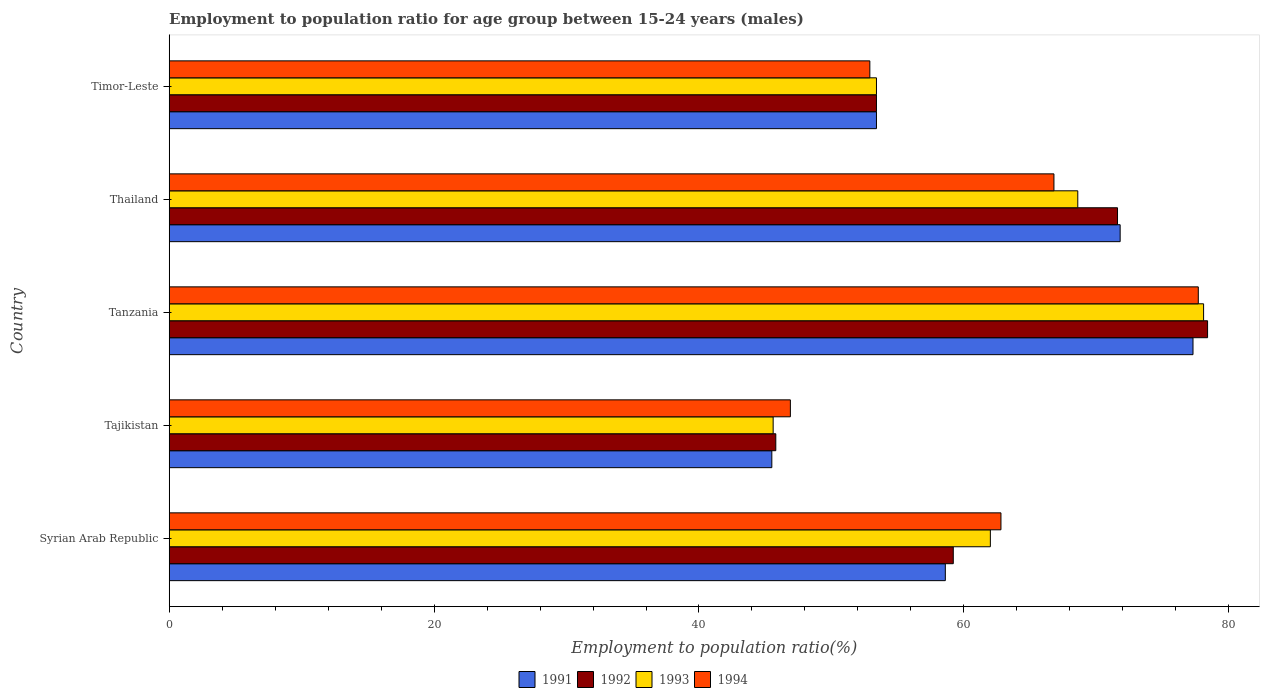How many different coloured bars are there?
Provide a succinct answer. 4. Are the number of bars per tick equal to the number of legend labels?
Keep it short and to the point. Yes. How many bars are there on the 4th tick from the bottom?
Provide a succinct answer. 4. What is the label of the 4th group of bars from the top?
Keep it short and to the point. Tajikistan. What is the employment to population ratio in 1991 in Thailand?
Your answer should be very brief. 71.8. Across all countries, what is the maximum employment to population ratio in 1991?
Ensure brevity in your answer.  77.3. Across all countries, what is the minimum employment to population ratio in 1992?
Ensure brevity in your answer.  45.8. In which country was the employment to population ratio in 1991 maximum?
Ensure brevity in your answer.  Tanzania. In which country was the employment to population ratio in 1993 minimum?
Your answer should be compact. Tajikistan. What is the total employment to population ratio in 1992 in the graph?
Keep it short and to the point. 308.4. What is the difference between the employment to population ratio in 1991 in Tajikistan and that in Tanzania?
Your response must be concise. -31.8. What is the difference between the employment to population ratio in 1991 in Syrian Arab Republic and the employment to population ratio in 1994 in Timor-Leste?
Ensure brevity in your answer.  5.7. What is the average employment to population ratio in 1992 per country?
Provide a short and direct response. 61.68. What is the difference between the employment to population ratio in 1991 and employment to population ratio in 1992 in Tajikistan?
Offer a very short reply. -0.3. In how many countries, is the employment to population ratio in 1993 greater than 68 %?
Keep it short and to the point. 2. What is the ratio of the employment to population ratio in 1992 in Tajikistan to that in Timor-Leste?
Provide a short and direct response. 0.86. What is the difference between the highest and the lowest employment to population ratio in 1991?
Offer a terse response. 31.8. In how many countries, is the employment to population ratio in 1991 greater than the average employment to population ratio in 1991 taken over all countries?
Ensure brevity in your answer.  2. Is it the case that in every country, the sum of the employment to population ratio in 1993 and employment to population ratio in 1994 is greater than the sum of employment to population ratio in 1991 and employment to population ratio in 1992?
Offer a terse response. No. What does the 1st bar from the top in Timor-Leste represents?
Your answer should be compact. 1994. What does the 4th bar from the bottom in Tajikistan represents?
Offer a terse response. 1994. How many bars are there?
Provide a short and direct response. 20. How many countries are there in the graph?
Your response must be concise. 5. Are the values on the major ticks of X-axis written in scientific E-notation?
Ensure brevity in your answer.  No. How are the legend labels stacked?
Ensure brevity in your answer.  Horizontal. What is the title of the graph?
Your response must be concise. Employment to population ratio for age group between 15-24 years (males). Does "1962" appear as one of the legend labels in the graph?
Your response must be concise. No. What is the label or title of the X-axis?
Make the answer very short. Employment to population ratio(%). What is the label or title of the Y-axis?
Provide a short and direct response. Country. What is the Employment to population ratio(%) in 1991 in Syrian Arab Republic?
Your answer should be compact. 58.6. What is the Employment to population ratio(%) in 1992 in Syrian Arab Republic?
Offer a very short reply. 59.2. What is the Employment to population ratio(%) in 1993 in Syrian Arab Republic?
Your answer should be very brief. 62. What is the Employment to population ratio(%) in 1994 in Syrian Arab Republic?
Offer a very short reply. 62.8. What is the Employment to population ratio(%) in 1991 in Tajikistan?
Provide a short and direct response. 45.5. What is the Employment to population ratio(%) in 1992 in Tajikistan?
Offer a very short reply. 45.8. What is the Employment to population ratio(%) of 1993 in Tajikistan?
Provide a short and direct response. 45.6. What is the Employment to population ratio(%) of 1994 in Tajikistan?
Keep it short and to the point. 46.9. What is the Employment to population ratio(%) in 1991 in Tanzania?
Keep it short and to the point. 77.3. What is the Employment to population ratio(%) of 1992 in Tanzania?
Offer a terse response. 78.4. What is the Employment to population ratio(%) in 1993 in Tanzania?
Give a very brief answer. 78.1. What is the Employment to population ratio(%) in 1994 in Tanzania?
Offer a terse response. 77.7. What is the Employment to population ratio(%) in 1991 in Thailand?
Your response must be concise. 71.8. What is the Employment to population ratio(%) in 1992 in Thailand?
Keep it short and to the point. 71.6. What is the Employment to population ratio(%) of 1993 in Thailand?
Your answer should be very brief. 68.6. What is the Employment to population ratio(%) in 1994 in Thailand?
Provide a short and direct response. 66.8. What is the Employment to population ratio(%) of 1991 in Timor-Leste?
Give a very brief answer. 53.4. What is the Employment to population ratio(%) in 1992 in Timor-Leste?
Your answer should be compact. 53.4. What is the Employment to population ratio(%) of 1993 in Timor-Leste?
Make the answer very short. 53.4. What is the Employment to population ratio(%) in 1994 in Timor-Leste?
Ensure brevity in your answer.  52.9. Across all countries, what is the maximum Employment to population ratio(%) in 1991?
Offer a terse response. 77.3. Across all countries, what is the maximum Employment to population ratio(%) in 1992?
Offer a terse response. 78.4. Across all countries, what is the maximum Employment to population ratio(%) of 1993?
Ensure brevity in your answer.  78.1. Across all countries, what is the maximum Employment to population ratio(%) of 1994?
Your answer should be very brief. 77.7. Across all countries, what is the minimum Employment to population ratio(%) in 1991?
Your response must be concise. 45.5. Across all countries, what is the minimum Employment to population ratio(%) of 1992?
Keep it short and to the point. 45.8. Across all countries, what is the minimum Employment to population ratio(%) in 1993?
Give a very brief answer. 45.6. Across all countries, what is the minimum Employment to population ratio(%) in 1994?
Your answer should be compact. 46.9. What is the total Employment to population ratio(%) in 1991 in the graph?
Your answer should be compact. 306.6. What is the total Employment to population ratio(%) in 1992 in the graph?
Your response must be concise. 308.4. What is the total Employment to population ratio(%) in 1993 in the graph?
Your response must be concise. 307.7. What is the total Employment to population ratio(%) of 1994 in the graph?
Ensure brevity in your answer.  307.1. What is the difference between the Employment to population ratio(%) of 1992 in Syrian Arab Republic and that in Tajikistan?
Keep it short and to the point. 13.4. What is the difference between the Employment to population ratio(%) in 1993 in Syrian Arab Republic and that in Tajikistan?
Your response must be concise. 16.4. What is the difference between the Employment to population ratio(%) of 1994 in Syrian Arab Republic and that in Tajikistan?
Your response must be concise. 15.9. What is the difference between the Employment to population ratio(%) in 1991 in Syrian Arab Republic and that in Tanzania?
Give a very brief answer. -18.7. What is the difference between the Employment to population ratio(%) of 1992 in Syrian Arab Republic and that in Tanzania?
Provide a succinct answer. -19.2. What is the difference between the Employment to population ratio(%) of 1993 in Syrian Arab Republic and that in Tanzania?
Give a very brief answer. -16.1. What is the difference between the Employment to population ratio(%) in 1994 in Syrian Arab Republic and that in Tanzania?
Your answer should be compact. -14.9. What is the difference between the Employment to population ratio(%) of 1991 in Syrian Arab Republic and that in Thailand?
Ensure brevity in your answer.  -13.2. What is the difference between the Employment to population ratio(%) in 1992 in Syrian Arab Republic and that in Thailand?
Your response must be concise. -12.4. What is the difference between the Employment to population ratio(%) of 1994 in Syrian Arab Republic and that in Thailand?
Make the answer very short. -4. What is the difference between the Employment to population ratio(%) in 1994 in Syrian Arab Republic and that in Timor-Leste?
Provide a succinct answer. 9.9. What is the difference between the Employment to population ratio(%) of 1991 in Tajikistan and that in Tanzania?
Provide a short and direct response. -31.8. What is the difference between the Employment to population ratio(%) of 1992 in Tajikistan and that in Tanzania?
Your answer should be very brief. -32.6. What is the difference between the Employment to population ratio(%) of 1993 in Tajikistan and that in Tanzania?
Ensure brevity in your answer.  -32.5. What is the difference between the Employment to population ratio(%) of 1994 in Tajikistan and that in Tanzania?
Ensure brevity in your answer.  -30.8. What is the difference between the Employment to population ratio(%) in 1991 in Tajikistan and that in Thailand?
Offer a terse response. -26.3. What is the difference between the Employment to population ratio(%) of 1992 in Tajikistan and that in Thailand?
Offer a terse response. -25.8. What is the difference between the Employment to population ratio(%) in 1993 in Tajikistan and that in Thailand?
Provide a succinct answer. -23. What is the difference between the Employment to population ratio(%) in 1994 in Tajikistan and that in Thailand?
Provide a short and direct response. -19.9. What is the difference between the Employment to population ratio(%) of 1991 in Tanzania and that in Thailand?
Offer a terse response. 5.5. What is the difference between the Employment to population ratio(%) in 1992 in Tanzania and that in Thailand?
Give a very brief answer. 6.8. What is the difference between the Employment to population ratio(%) in 1993 in Tanzania and that in Thailand?
Offer a very short reply. 9.5. What is the difference between the Employment to population ratio(%) of 1991 in Tanzania and that in Timor-Leste?
Keep it short and to the point. 23.9. What is the difference between the Employment to population ratio(%) of 1993 in Tanzania and that in Timor-Leste?
Your answer should be very brief. 24.7. What is the difference between the Employment to population ratio(%) of 1994 in Tanzania and that in Timor-Leste?
Offer a very short reply. 24.8. What is the difference between the Employment to population ratio(%) of 1991 in Thailand and that in Timor-Leste?
Offer a very short reply. 18.4. What is the difference between the Employment to population ratio(%) in 1992 in Thailand and that in Timor-Leste?
Provide a short and direct response. 18.2. What is the difference between the Employment to population ratio(%) in 1993 in Thailand and that in Timor-Leste?
Offer a very short reply. 15.2. What is the difference between the Employment to population ratio(%) of 1992 in Syrian Arab Republic and the Employment to population ratio(%) of 1993 in Tajikistan?
Keep it short and to the point. 13.6. What is the difference between the Employment to population ratio(%) of 1992 in Syrian Arab Republic and the Employment to population ratio(%) of 1994 in Tajikistan?
Your answer should be very brief. 12.3. What is the difference between the Employment to population ratio(%) of 1993 in Syrian Arab Republic and the Employment to population ratio(%) of 1994 in Tajikistan?
Keep it short and to the point. 15.1. What is the difference between the Employment to population ratio(%) of 1991 in Syrian Arab Republic and the Employment to population ratio(%) of 1992 in Tanzania?
Keep it short and to the point. -19.8. What is the difference between the Employment to population ratio(%) in 1991 in Syrian Arab Republic and the Employment to population ratio(%) in 1993 in Tanzania?
Offer a terse response. -19.5. What is the difference between the Employment to population ratio(%) of 1991 in Syrian Arab Republic and the Employment to population ratio(%) of 1994 in Tanzania?
Provide a succinct answer. -19.1. What is the difference between the Employment to population ratio(%) in 1992 in Syrian Arab Republic and the Employment to population ratio(%) in 1993 in Tanzania?
Make the answer very short. -18.9. What is the difference between the Employment to population ratio(%) of 1992 in Syrian Arab Republic and the Employment to population ratio(%) of 1994 in Tanzania?
Ensure brevity in your answer.  -18.5. What is the difference between the Employment to population ratio(%) in 1993 in Syrian Arab Republic and the Employment to population ratio(%) in 1994 in Tanzania?
Provide a short and direct response. -15.7. What is the difference between the Employment to population ratio(%) of 1991 in Syrian Arab Republic and the Employment to population ratio(%) of 1993 in Thailand?
Make the answer very short. -10. What is the difference between the Employment to population ratio(%) in 1991 in Syrian Arab Republic and the Employment to population ratio(%) in 1994 in Thailand?
Provide a succinct answer. -8.2. What is the difference between the Employment to population ratio(%) in 1992 in Syrian Arab Republic and the Employment to population ratio(%) in 1993 in Thailand?
Offer a terse response. -9.4. What is the difference between the Employment to population ratio(%) in 1991 in Syrian Arab Republic and the Employment to population ratio(%) in 1992 in Timor-Leste?
Provide a succinct answer. 5.2. What is the difference between the Employment to population ratio(%) in 1991 in Syrian Arab Republic and the Employment to population ratio(%) in 1993 in Timor-Leste?
Make the answer very short. 5.2. What is the difference between the Employment to population ratio(%) in 1992 in Syrian Arab Republic and the Employment to population ratio(%) in 1994 in Timor-Leste?
Offer a terse response. 6.3. What is the difference between the Employment to population ratio(%) of 1991 in Tajikistan and the Employment to population ratio(%) of 1992 in Tanzania?
Provide a short and direct response. -32.9. What is the difference between the Employment to population ratio(%) in 1991 in Tajikistan and the Employment to population ratio(%) in 1993 in Tanzania?
Your response must be concise. -32.6. What is the difference between the Employment to population ratio(%) of 1991 in Tajikistan and the Employment to population ratio(%) of 1994 in Tanzania?
Keep it short and to the point. -32.2. What is the difference between the Employment to population ratio(%) of 1992 in Tajikistan and the Employment to population ratio(%) of 1993 in Tanzania?
Your answer should be very brief. -32.3. What is the difference between the Employment to population ratio(%) in 1992 in Tajikistan and the Employment to population ratio(%) in 1994 in Tanzania?
Your answer should be compact. -31.9. What is the difference between the Employment to population ratio(%) in 1993 in Tajikistan and the Employment to population ratio(%) in 1994 in Tanzania?
Provide a succinct answer. -32.1. What is the difference between the Employment to population ratio(%) in 1991 in Tajikistan and the Employment to population ratio(%) in 1992 in Thailand?
Provide a short and direct response. -26.1. What is the difference between the Employment to population ratio(%) in 1991 in Tajikistan and the Employment to population ratio(%) in 1993 in Thailand?
Keep it short and to the point. -23.1. What is the difference between the Employment to population ratio(%) of 1991 in Tajikistan and the Employment to population ratio(%) of 1994 in Thailand?
Offer a very short reply. -21.3. What is the difference between the Employment to population ratio(%) of 1992 in Tajikistan and the Employment to population ratio(%) of 1993 in Thailand?
Keep it short and to the point. -22.8. What is the difference between the Employment to population ratio(%) in 1993 in Tajikistan and the Employment to population ratio(%) in 1994 in Thailand?
Offer a terse response. -21.2. What is the difference between the Employment to population ratio(%) in 1991 in Tajikistan and the Employment to population ratio(%) in 1992 in Timor-Leste?
Offer a very short reply. -7.9. What is the difference between the Employment to population ratio(%) in 1991 in Tajikistan and the Employment to population ratio(%) in 1994 in Timor-Leste?
Make the answer very short. -7.4. What is the difference between the Employment to population ratio(%) of 1992 in Tajikistan and the Employment to population ratio(%) of 1994 in Timor-Leste?
Make the answer very short. -7.1. What is the difference between the Employment to population ratio(%) of 1993 in Tajikistan and the Employment to population ratio(%) of 1994 in Timor-Leste?
Give a very brief answer. -7.3. What is the difference between the Employment to population ratio(%) in 1991 in Tanzania and the Employment to population ratio(%) in 1994 in Thailand?
Give a very brief answer. 10.5. What is the difference between the Employment to population ratio(%) of 1993 in Tanzania and the Employment to population ratio(%) of 1994 in Thailand?
Give a very brief answer. 11.3. What is the difference between the Employment to population ratio(%) in 1991 in Tanzania and the Employment to population ratio(%) in 1992 in Timor-Leste?
Your answer should be compact. 23.9. What is the difference between the Employment to population ratio(%) in 1991 in Tanzania and the Employment to population ratio(%) in 1993 in Timor-Leste?
Your answer should be compact. 23.9. What is the difference between the Employment to population ratio(%) of 1991 in Tanzania and the Employment to population ratio(%) of 1994 in Timor-Leste?
Keep it short and to the point. 24.4. What is the difference between the Employment to population ratio(%) of 1992 in Tanzania and the Employment to population ratio(%) of 1993 in Timor-Leste?
Offer a terse response. 25. What is the difference between the Employment to population ratio(%) of 1992 in Tanzania and the Employment to population ratio(%) of 1994 in Timor-Leste?
Make the answer very short. 25.5. What is the difference between the Employment to population ratio(%) in 1993 in Tanzania and the Employment to population ratio(%) in 1994 in Timor-Leste?
Offer a very short reply. 25.2. What is the difference between the Employment to population ratio(%) of 1991 in Thailand and the Employment to population ratio(%) of 1992 in Timor-Leste?
Offer a very short reply. 18.4. What is the difference between the Employment to population ratio(%) in 1991 in Thailand and the Employment to population ratio(%) in 1993 in Timor-Leste?
Your answer should be compact. 18.4. What is the difference between the Employment to population ratio(%) in 1992 in Thailand and the Employment to population ratio(%) in 1993 in Timor-Leste?
Offer a terse response. 18.2. What is the average Employment to population ratio(%) in 1991 per country?
Make the answer very short. 61.32. What is the average Employment to population ratio(%) in 1992 per country?
Ensure brevity in your answer.  61.68. What is the average Employment to population ratio(%) of 1993 per country?
Offer a terse response. 61.54. What is the average Employment to population ratio(%) of 1994 per country?
Give a very brief answer. 61.42. What is the difference between the Employment to population ratio(%) of 1991 and Employment to population ratio(%) of 1994 in Syrian Arab Republic?
Give a very brief answer. -4.2. What is the difference between the Employment to population ratio(%) of 1992 and Employment to population ratio(%) of 1993 in Syrian Arab Republic?
Offer a terse response. -2.8. What is the difference between the Employment to population ratio(%) of 1991 and Employment to population ratio(%) of 1992 in Tajikistan?
Your response must be concise. -0.3. What is the difference between the Employment to population ratio(%) in 1991 and Employment to population ratio(%) in 1993 in Tajikistan?
Offer a terse response. -0.1. What is the difference between the Employment to population ratio(%) in 1993 and Employment to population ratio(%) in 1994 in Tajikistan?
Your answer should be compact. -1.3. What is the difference between the Employment to population ratio(%) of 1991 and Employment to population ratio(%) of 1994 in Tanzania?
Ensure brevity in your answer.  -0.4. What is the difference between the Employment to population ratio(%) of 1992 and Employment to population ratio(%) of 1993 in Tanzania?
Your answer should be compact. 0.3. What is the difference between the Employment to population ratio(%) in 1991 and Employment to population ratio(%) in 1992 in Timor-Leste?
Your answer should be compact. 0. What is the difference between the Employment to population ratio(%) in 1993 and Employment to population ratio(%) in 1994 in Timor-Leste?
Give a very brief answer. 0.5. What is the ratio of the Employment to population ratio(%) in 1991 in Syrian Arab Republic to that in Tajikistan?
Your answer should be compact. 1.29. What is the ratio of the Employment to population ratio(%) of 1992 in Syrian Arab Republic to that in Tajikistan?
Give a very brief answer. 1.29. What is the ratio of the Employment to population ratio(%) in 1993 in Syrian Arab Republic to that in Tajikistan?
Give a very brief answer. 1.36. What is the ratio of the Employment to population ratio(%) of 1994 in Syrian Arab Republic to that in Tajikistan?
Offer a terse response. 1.34. What is the ratio of the Employment to population ratio(%) in 1991 in Syrian Arab Republic to that in Tanzania?
Keep it short and to the point. 0.76. What is the ratio of the Employment to population ratio(%) of 1992 in Syrian Arab Republic to that in Tanzania?
Give a very brief answer. 0.76. What is the ratio of the Employment to population ratio(%) of 1993 in Syrian Arab Republic to that in Tanzania?
Offer a terse response. 0.79. What is the ratio of the Employment to population ratio(%) of 1994 in Syrian Arab Republic to that in Tanzania?
Your response must be concise. 0.81. What is the ratio of the Employment to population ratio(%) in 1991 in Syrian Arab Republic to that in Thailand?
Give a very brief answer. 0.82. What is the ratio of the Employment to population ratio(%) of 1992 in Syrian Arab Republic to that in Thailand?
Provide a short and direct response. 0.83. What is the ratio of the Employment to population ratio(%) of 1993 in Syrian Arab Republic to that in Thailand?
Your response must be concise. 0.9. What is the ratio of the Employment to population ratio(%) of 1994 in Syrian Arab Republic to that in Thailand?
Offer a terse response. 0.94. What is the ratio of the Employment to population ratio(%) in 1991 in Syrian Arab Republic to that in Timor-Leste?
Your response must be concise. 1.1. What is the ratio of the Employment to population ratio(%) of 1992 in Syrian Arab Republic to that in Timor-Leste?
Keep it short and to the point. 1.11. What is the ratio of the Employment to population ratio(%) of 1993 in Syrian Arab Republic to that in Timor-Leste?
Ensure brevity in your answer.  1.16. What is the ratio of the Employment to population ratio(%) in 1994 in Syrian Arab Republic to that in Timor-Leste?
Your response must be concise. 1.19. What is the ratio of the Employment to population ratio(%) in 1991 in Tajikistan to that in Tanzania?
Ensure brevity in your answer.  0.59. What is the ratio of the Employment to population ratio(%) in 1992 in Tajikistan to that in Tanzania?
Your response must be concise. 0.58. What is the ratio of the Employment to population ratio(%) in 1993 in Tajikistan to that in Tanzania?
Make the answer very short. 0.58. What is the ratio of the Employment to population ratio(%) of 1994 in Tajikistan to that in Tanzania?
Offer a terse response. 0.6. What is the ratio of the Employment to population ratio(%) of 1991 in Tajikistan to that in Thailand?
Give a very brief answer. 0.63. What is the ratio of the Employment to population ratio(%) in 1992 in Tajikistan to that in Thailand?
Offer a terse response. 0.64. What is the ratio of the Employment to population ratio(%) in 1993 in Tajikistan to that in Thailand?
Provide a succinct answer. 0.66. What is the ratio of the Employment to population ratio(%) of 1994 in Tajikistan to that in Thailand?
Your answer should be compact. 0.7. What is the ratio of the Employment to population ratio(%) in 1991 in Tajikistan to that in Timor-Leste?
Provide a short and direct response. 0.85. What is the ratio of the Employment to population ratio(%) in 1992 in Tajikistan to that in Timor-Leste?
Offer a very short reply. 0.86. What is the ratio of the Employment to population ratio(%) of 1993 in Tajikistan to that in Timor-Leste?
Give a very brief answer. 0.85. What is the ratio of the Employment to population ratio(%) in 1994 in Tajikistan to that in Timor-Leste?
Provide a succinct answer. 0.89. What is the ratio of the Employment to population ratio(%) in 1991 in Tanzania to that in Thailand?
Provide a succinct answer. 1.08. What is the ratio of the Employment to population ratio(%) of 1992 in Tanzania to that in Thailand?
Offer a very short reply. 1.09. What is the ratio of the Employment to population ratio(%) in 1993 in Tanzania to that in Thailand?
Give a very brief answer. 1.14. What is the ratio of the Employment to population ratio(%) in 1994 in Tanzania to that in Thailand?
Ensure brevity in your answer.  1.16. What is the ratio of the Employment to population ratio(%) of 1991 in Tanzania to that in Timor-Leste?
Give a very brief answer. 1.45. What is the ratio of the Employment to population ratio(%) of 1992 in Tanzania to that in Timor-Leste?
Provide a succinct answer. 1.47. What is the ratio of the Employment to population ratio(%) of 1993 in Tanzania to that in Timor-Leste?
Offer a terse response. 1.46. What is the ratio of the Employment to population ratio(%) in 1994 in Tanzania to that in Timor-Leste?
Your response must be concise. 1.47. What is the ratio of the Employment to population ratio(%) of 1991 in Thailand to that in Timor-Leste?
Provide a short and direct response. 1.34. What is the ratio of the Employment to population ratio(%) in 1992 in Thailand to that in Timor-Leste?
Your response must be concise. 1.34. What is the ratio of the Employment to population ratio(%) of 1993 in Thailand to that in Timor-Leste?
Offer a very short reply. 1.28. What is the ratio of the Employment to population ratio(%) of 1994 in Thailand to that in Timor-Leste?
Make the answer very short. 1.26. What is the difference between the highest and the second highest Employment to population ratio(%) of 1991?
Provide a short and direct response. 5.5. What is the difference between the highest and the second highest Employment to population ratio(%) in 1992?
Ensure brevity in your answer.  6.8. What is the difference between the highest and the second highest Employment to population ratio(%) in 1994?
Provide a succinct answer. 10.9. What is the difference between the highest and the lowest Employment to population ratio(%) of 1991?
Keep it short and to the point. 31.8. What is the difference between the highest and the lowest Employment to population ratio(%) of 1992?
Your response must be concise. 32.6. What is the difference between the highest and the lowest Employment to population ratio(%) of 1993?
Provide a short and direct response. 32.5. What is the difference between the highest and the lowest Employment to population ratio(%) of 1994?
Provide a short and direct response. 30.8. 